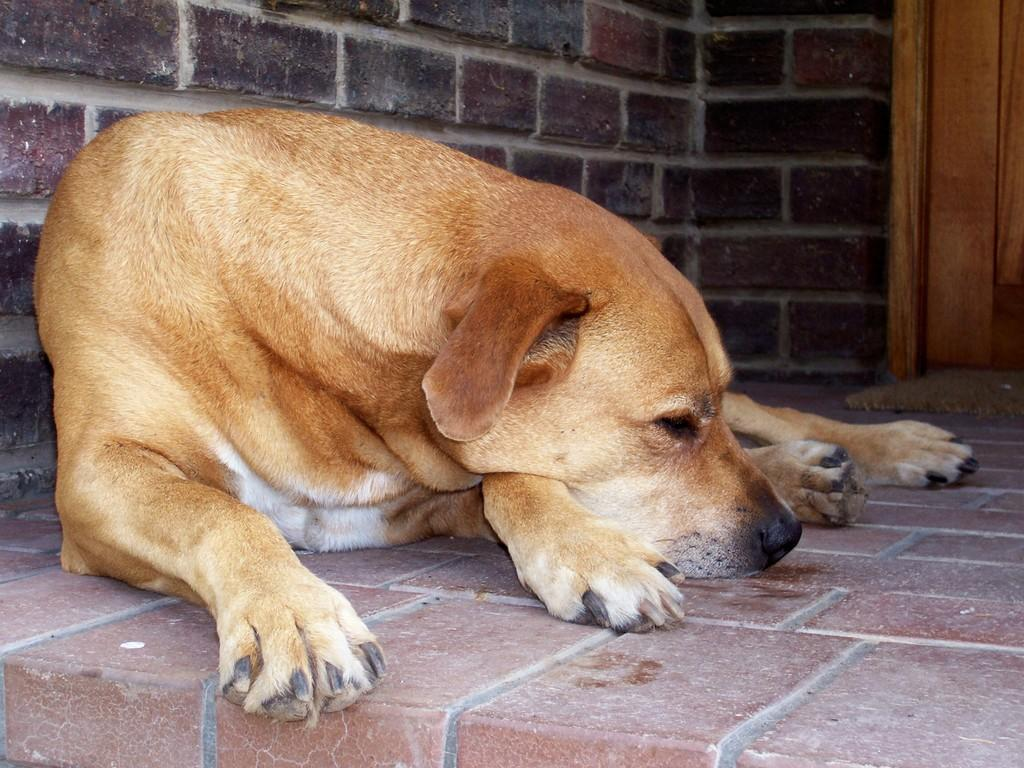What is the main subject in the center of the image? There is a dog in the center of the image. Can you describe anything in the background of the image? There is a door in the background of the image. What type of hook can be seen hanging from the cloud in the image? There is no hook or cloud present in the image; it only features a dog and a door in the background. 